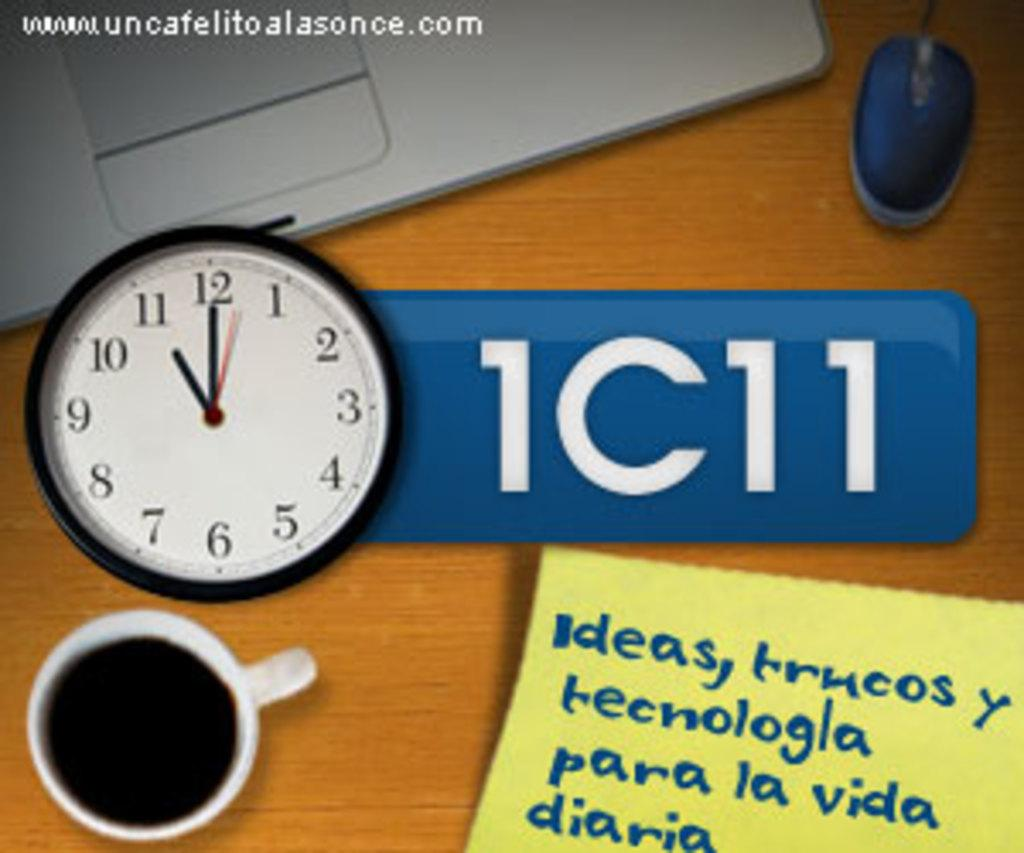<image>
Relay a brief, clear account of the picture shown. A clock, mouse, mug, and signs are on a desk and one of the signs has the number 1 on it. 